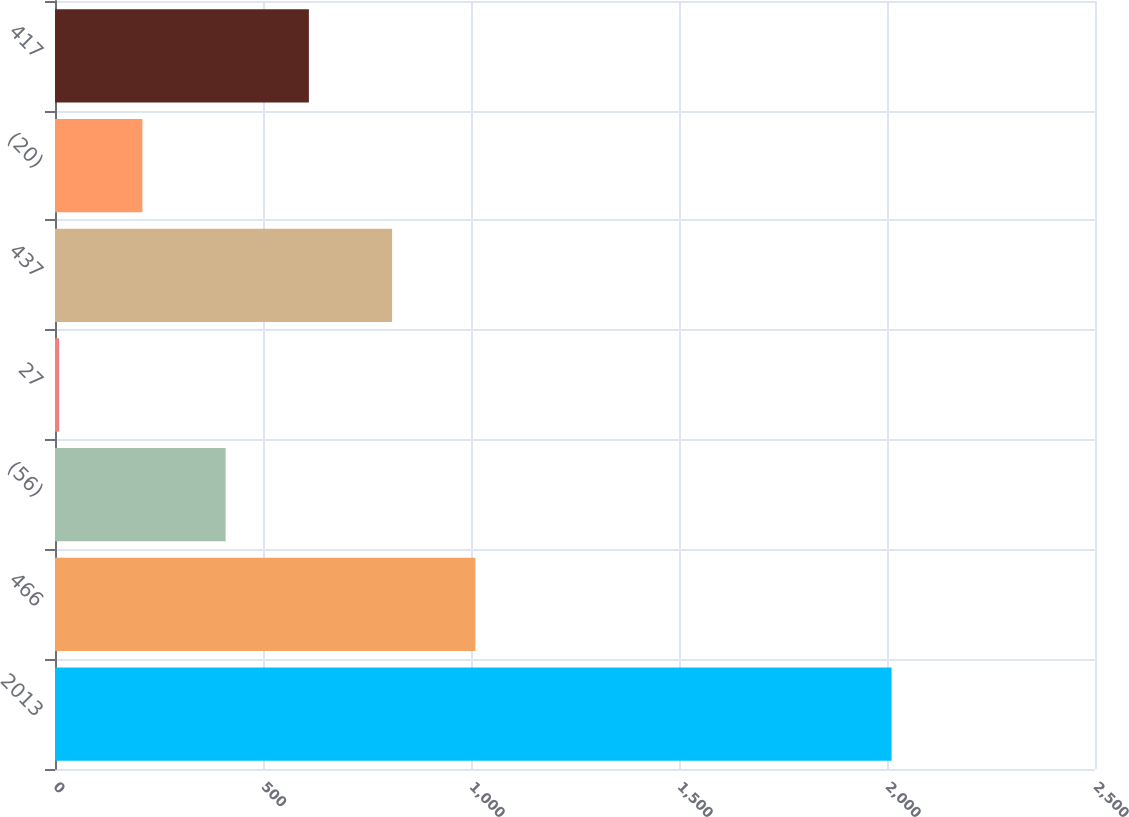Convert chart. <chart><loc_0><loc_0><loc_500><loc_500><bar_chart><fcel>2013<fcel>466<fcel>(56)<fcel>27<fcel>437<fcel>(20)<fcel>417<nl><fcel>2011<fcel>1010.5<fcel>410.2<fcel>10<fcel>810.4<fcel>210.1<fcel>610.3<nl></chart> 